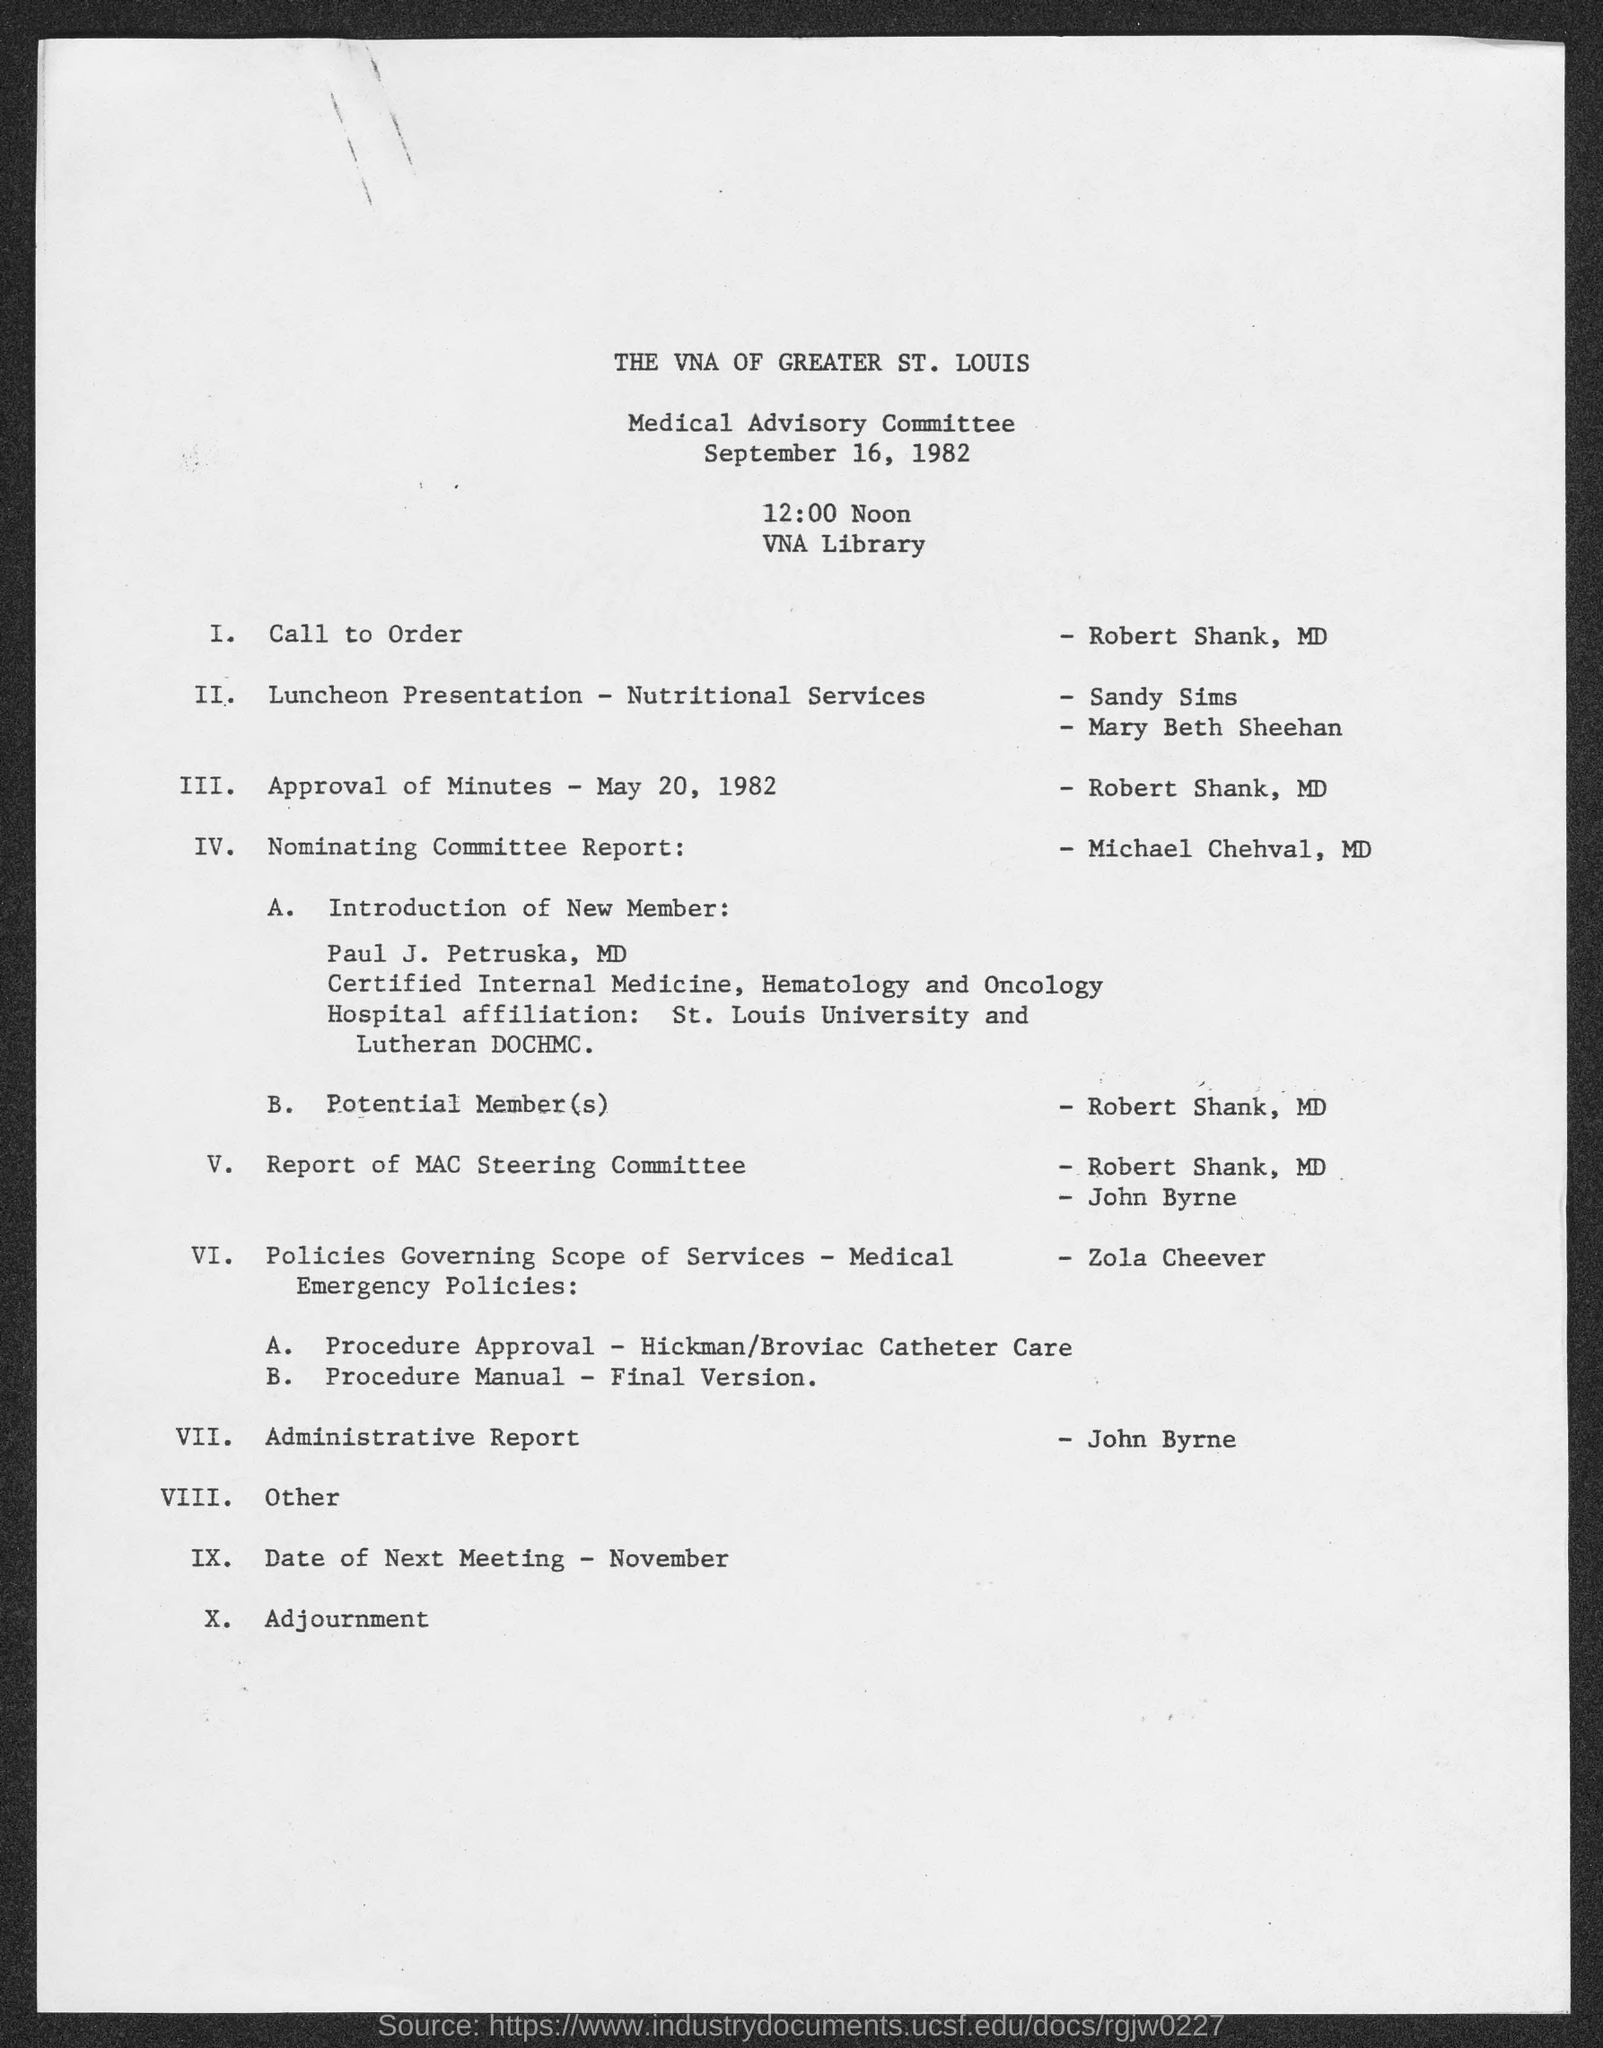What is the date of Medical Advisory Committee?
Your response must be concise. SEPTEMBER 16, 1982. Which is the venue of the Committee?
Your answer should be compact. VNA LIBRARY. Who deals the Call to Order?
Make the answer very short. ROBERT SHANK. Which topic is handled by Michael Chehval?
Your answer should be very brief. NOMINATING COMMITTEE REPORT. 